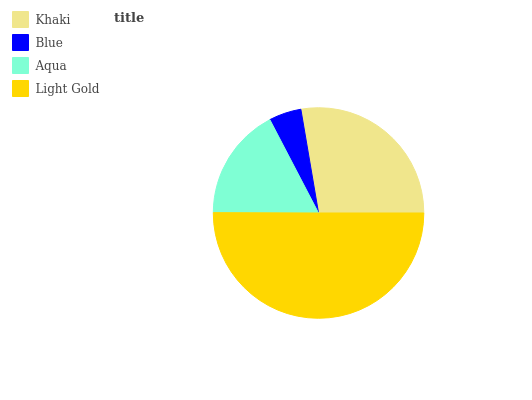Is Blue the minimum?
Answer yes or no. Yes. Is Light Gold the maximum?
Answer yes or no. Yes. Is Aqua the minimum?
Answer yes or no. No. Is Aqua the maximum?
Answer yes or no. No. Is Aqua greater than Blue?
Answer yes or no. Yes. Is Blue less than Aqua?
Answer yes or no. Yes. Is Blue greater than Aqua?
Answer yes or no. No. Is Aqua less than Blue?
Answer yes or no. No. Is Khaki the high median?
Answer yes or no. Yes. Is Aqua the low median?
Answer yes or no. Yes. Is Blue the high median?
Answer yes or no. No. Is Khaki the low median?
Answer yes or no. No. 